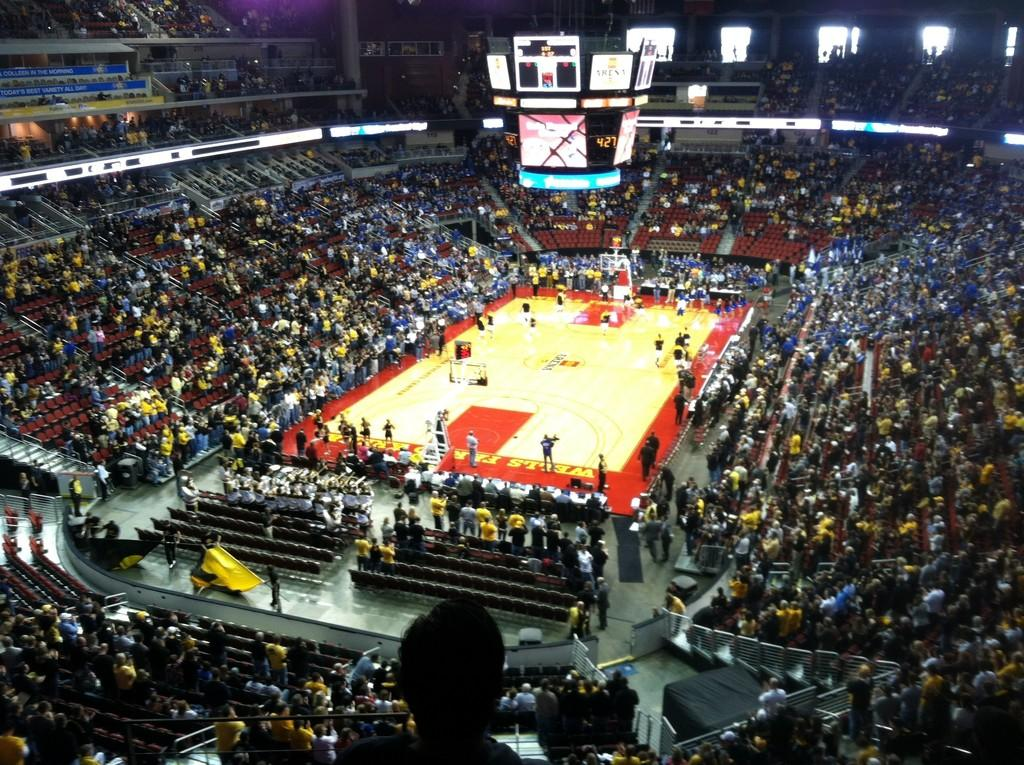<image>
Share a concise interpretation of the image provided. A Basketball arena shows 4:27 on the scoreboard. 